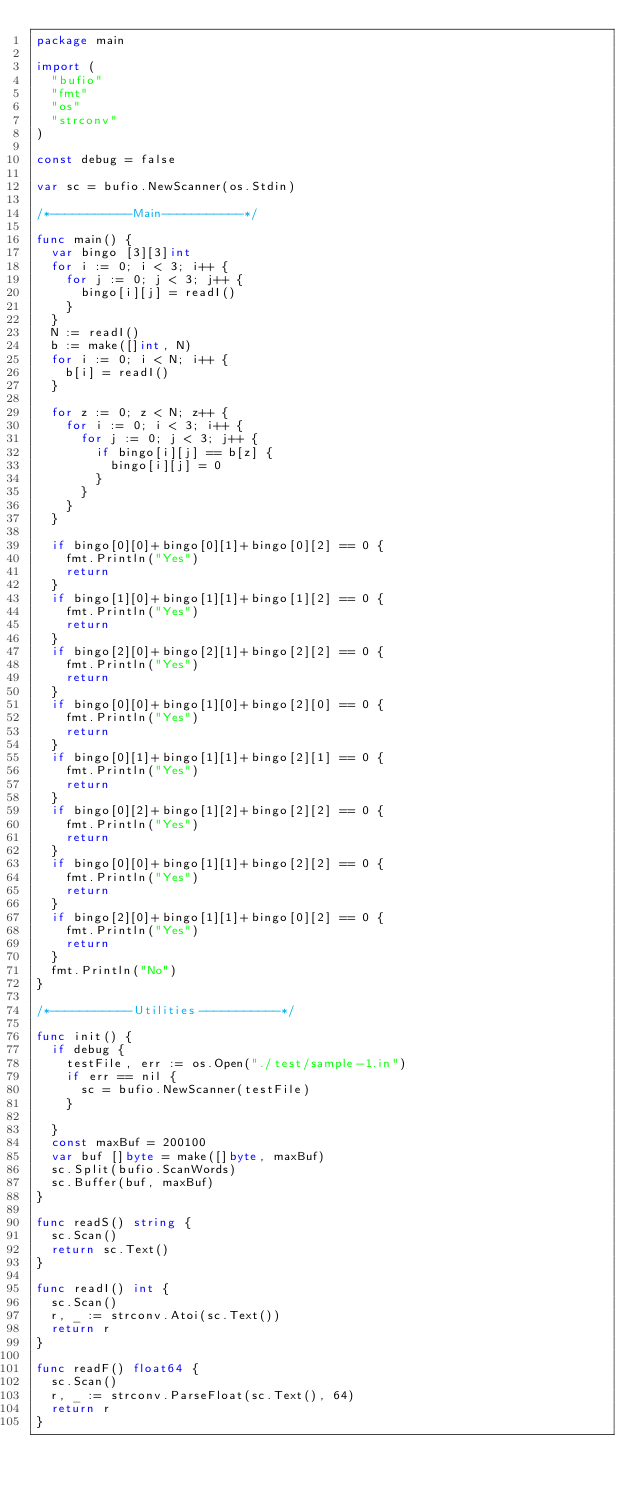<code> <loc_0><loc_0><loc_500><loc_500><_Go_>package main

import (
	"bufio"
	"fmt"
	"os"
	"strconv"
)

const debug = false

var sc = bufio.NewScanner(os.Stdin)

/*-----------Main-----------*/

func main() {
	var bingo [3][3]int
	for i := 0; i < 3; i++ {
		for j := 0; j < 3; j++ {
			bingo[i][j] = readI()
		}
	}
	N := readI()
	b := make([]int, N)
	for i := 0; i < N; i++ {
		b[i] = readI()
	}

	for z := 0; z < N; z++ {
		for i := 0; i < 3; i++ {
			for j := 0; j < 3; j++ {
				if bingo[i][j] == b[z] {
					bingo[i][j] = 0
				}
			}
		}
	}

	if bingo[0][0]+bingo[0][1]+bingo[0][2] == 0 {
		fmt.Println("Yes")
		return
	}
	if bingo[1][0]+bingo[1][1]+bingo[1][2] == 0 {
		fmt.Println("Yes")
		return
	}
	if bingo[2][0]+bingo[2][1]+bingo[2][2] == 0 {
		fmt.Println("Yes")
		return
	}
	if bingo[0][0]+bingo[1][0]+bingo[2][0] == 0 {
		fmt.Println("Yes")
		return
	}
	if bingo[0][1]+bingo[1][1]+bingo[2][1] == 0 {
		fmt.Println("Yes")
		return
	}
	if bingo[0][2]+bingo[1][2]+bingo[2][2] == 0 {
		fmt.Println("Yes")
		return
	}
	if bingo[0][0]+bingo[1][1]+bingo[2][2] == 0 {
		fmt.Println("Yes")
		return
	}
	if bingo[2][0]+bingo[1][1]+bingo[0][2] == 0 {
		fmt.Println("Yes")
		return
	}
	fmt.Println("No")
}

/*-----------Utilities-----------*/

func init() {
	if debug {
		testFile, err := os.Open("./test/sample-1.in")
		if err == nil {
			sc = bufio.NewScanner(testFile)
		}

	}
	const maxBuf = 200100
	var buf []byte = make([]byte, maxBuf)
	sc.Split(bufio.ScanWords)
	sc.Buffer(buf, maxBuf)
}

func readS() string {
	sc.Scan()
	return sc.Text()
}

func readI() int {
	sc.Scan()
	r, _ := strconv.Atoi(sc.Text())
	return r
}

func readF() float64 {
	sc.Scan()
	r, _ := strconv.ParseFloat(sc.Text(), 64)
	return r
}
</code> 